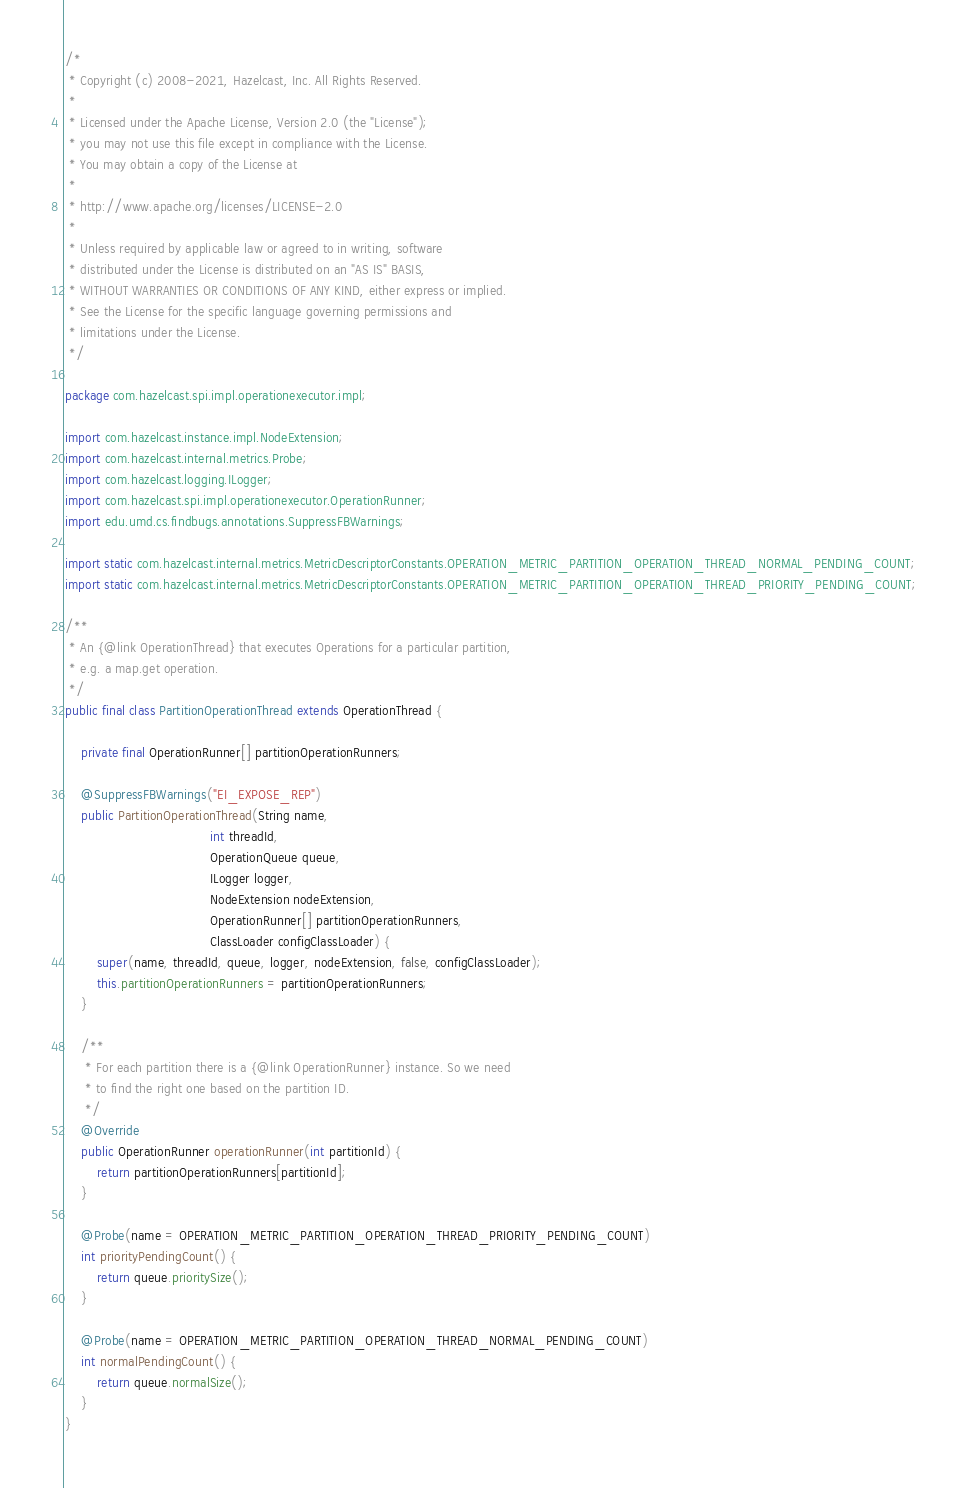Convert code to text. <code><loc_0><loc_0><loc_500><loc_500><_Java_>/*
 * Copyright (c) 2008-2021, Hazelcast, Inc. All Rights Reserved.
 *
 * Licensed under the Apache License, Version 2.0 (the "License");
 * you may not use this file except in compliance with the License.
 * You may obtain a copy of the License at
 *
 * http://www.apache.org/licenses/LICENSE-2.0
 *
 * Unless required by applicable law or agreed to in writing, software
 * distributed under the License is distributed on an "AS IS" BASIS,
 * WITHOUT WARRANTIES OR CONDITIONS OF ANY KIND, either express or implied.
 * See the License for the specific language governing permissions and
 * limitations under the License.
 */

package com.hazelcast.spi.impl.operationexecutor.impl;

import com.hazelcast.instance.impl.NodeExtension;
import com.hazelcast.internal.metrics.Probe;
import com.hazelcast.logging.ILogger;
import com.hazelcast.spi.impl.operationexecutor.OperationRunner;
import edu.umd.cs.findbugs.annotations.SuppressFBWarnings;

import static com.hazelcast.internal.metrics.MetricDescriptorConstants.OPERATION_METRIC_PARTITION_OPERATION_THREAD_NORMAL_PENDING_COUNT;
import static com.hazelcast.internal.metrics.MetricDescriptorConstants.OPERATION_METRIC_PARTITION_OPERATION_THREAD_PRIORITY_PENDING_COUNT;

/**
 * An {@link OperationThread} that executes Operations for a particular partition,
 * e.g. a map.get operation.
 */
public final class PartitionOperationThread extends OperationThread {

    private final OperationRunner[] partitionOperationRunners;

    @SuppressFBWarnings("EI_EXPOSE_REP")
    public PartitionOperationThread(String name,
                                    int threadId,
                                    OperationQueue queue,
                                    ILogger logger,
                                    NodeExtension nodeExtension,
                                    OperationRunner[] partitionOperationRunners,
                                    ClassLoader configClassLoader) {
        super(name, threadId, queue, logger, nodeExtension, false, configClassLoader);
        this.partitionOperationRunners = partitionOperationRunners;
    }

    /**
     * For each partition there is a {@link OperationRunner} instance. So we need
     * to find the right one based on the partition ID.
     */
    @Override
    public OperationRunner operationRunner(int partitionId) {
        return partitionOperationRunners[partitionId];
    }

    @Probe(name = OPERATION_METRIC_PARTITION_OPERATION_THREAD_PRIORITY_PENDING_COUNT)
    int priorityPendingCount() {
        return queue.prioritySize();
    }

    @Probe(name = OPERATION_METRIC_PARTITION_OPERATION_THREAD_NORMAL_PENDING_COUNT)
    int normalPendingCount() {
        return queue.normalSize();
    }
}
</code> 